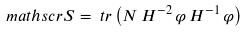<formula> <loc_0><loc_0><loc_500><loc_500>\ m a t h s c r { S } & = \ t r \left ( N \, H ^ { - 2 } \, \varphi \, H ^ { - 1 } \, \varphi \right )</formula> 